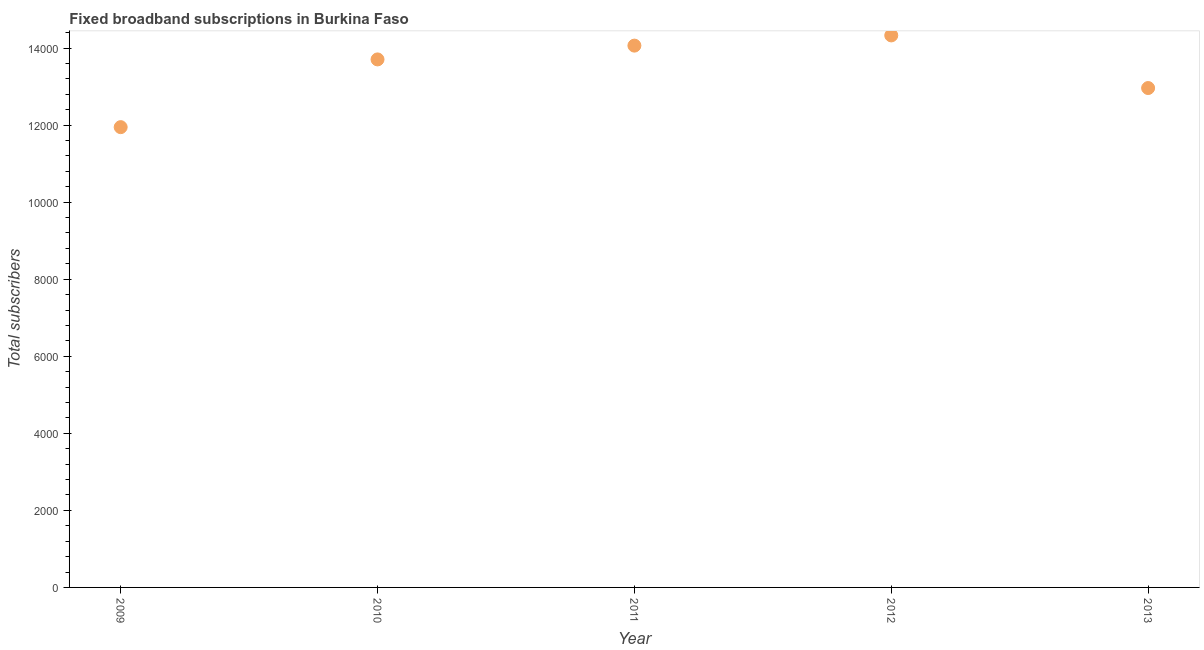What is the total number of fixed broadband subscriptions in 2011?
Offer a very short reply. 1.41e+04. Across all years, what is the maximum total number of fixed broadband subscriptions?
Provide a short and direct response. 1.43e+04. Across all years, what is the minimum total number of fixed broadband subscriptions?
Your response must be concise. 1.19e+04. What is the sum of the total number of fixed broadband subscriptions?
Ensure brevity in your answer.  6.70e+04. What is the difference between the total number of fixed broadband subscriptions in 2010 and 2011?
Make the answer very short. -358. What is the average total number of fixed broadband subscriptions per year?
Your answer should be compact. 1.34e+04. What is the median total number of fixed broadband subscriptions?
Offer a terse response. 1.37e+04. Do a majority of the years between 2013 and 2010 (inclusive) have total number of fixed broadband subscriptions greater than 4000 ?
Ensure brevity in your answer.  Yes. What is the ratio of the total number of fixed broadband subscriptions in 2009 to that in 2013?
Your response must be concise. 0.92. Is the total number of fixed broadband subscriptions in 2010 less than that in 2011?
Offer a very short reply. Yes. What is the difference between the highest and the second highest total number of fixed broadband subscriptions?
Your answer should be very brief. 265. Is the sum of the total number of fixed broadband subscriptions in 2011 and 2012 greater than the maximum total number of fixed broadband subscriptions across all years?
Offer a very short reply. Yes. What is the difference between the highest and the lowest total number of fixed broadband subscriptions?
Provide a short and direct response. 2381. Does the total number of fixed broadband subscriptions monotonically increase over the years?
Give a very brief answer. No. How many dotlines are there?
Provide a succinct answer. 1. Are the values on the major ticks of Y-axis written in scientific E-notation?
Keep it short and to the point. No. What is the title of the graph?
Offer a terse response. Fixed broadband subscriptions in Burkina Faso. What is the label or title of the Y-axis?
Your answer should be compact. Total subscribers. What is the Total subscribers in 2009?
Make the answer very short. 1.19e+04. What is the Total subscribers in 2010?
Your answer should be compact. 1.37e+04. What is the Total subscribers in 2011?
Provide a short and direct response. 1.41e+04. What is the Total subscribers in 2012?
Keep it short and to the point. 1.43e+04. What is the Total subscribers in 2013?
Provide a succinct answer. 1.30e+04. What is the difference between the Total subscribers in 2009 and 2010?
Give a very brief answer. -1758. What is the difference between the Total subscribers in 2009 and 2011?
Offer a terse response. -2116. What is the difference between the Total subscribers in 2009 and 2012?
Offer a terse response. -2381. What is the difference between the Total subscribers in 2009 and 2013?
Your answer should be compact. -1015. What is the difference between the Total subscribers in 2010 and 2011?
Make the answer very short. -358. What is the difference between the Total subscribers in 2010 and 2012?
Keep it short and to the point. -623. What is the difference between the Total subscribers in 2010 and 2013?
Your response must be concise. 743. What is the difference between the Total subscribers in 2011 and 2012?
Your answer should be compact. -265. What is the difference between the Total subscribers in 2011 and 2013?
Provide a short and direct response. 1101. What is the difference between the Total subscribers in 2012 and 2013?
Your answer should be very brief. 1366. What is the ratio of the Total subscribers in 2009 to that in 2010?
Offer a very short reply. 0.87. What is the ratio of the Total subscribers in 2009 to that in 2012?
Your answer should be compact. 0.83. What is the ratio of the Total subscribers in 2009 to that in 2013?
Your response must be concise. 0.92. What is the ratio of the Total subscribers in 2010 to that in 2011?
Give a very brief answer. 0.97. What is the ratio of the Total subscribers in 2010 to that in 2013?
Your answer should be compact. 1.06. What is the ratio of the Total subscribers in 2011 to that in 2013?
Your response must be concise. 1.08. What is the ratio of the Total subscribers in 2012 to that in 2013?
Give a very brief answer. 1.1. 